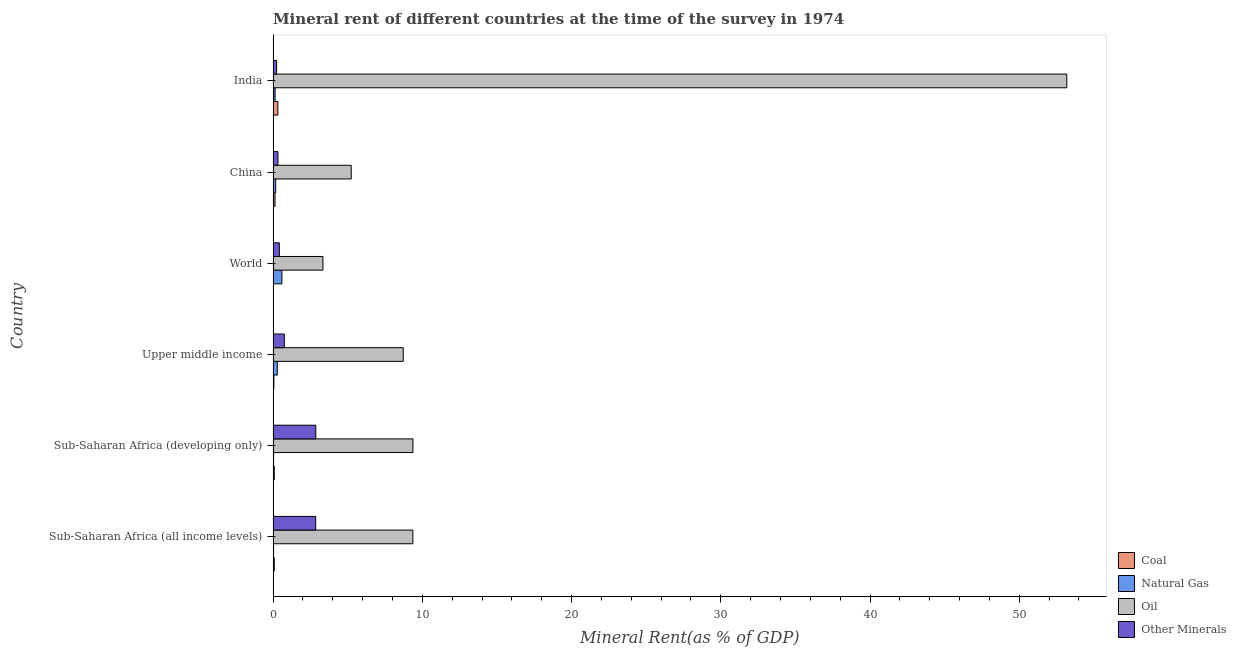Are the number of bars per tick equal to the number of legend labels?
Offer a very short reply. Yes. What is the label of the 4th group of bars from the top?
Provide a short and direct response. Upper middle income. What is the coal rent in Sub-Saharan Africa (developing only)?
Your response must be concise. 0.08. Across all countries, what is the maximum oil rent?
Ensure brevity in your answer.  53.18. Across all countries, what is the minimum  rent of other minerals?
Make the answer very short. 0.23. In which country was the  rent of other minerals minimum?
Offer a terse response. India. What is the total  rent of other minerals in the graph?
Your answer should be compact. 7.44. What is the difference between the coal rent in India and that in Sub-Saharan Africa (developing only)?
Provide a succinct answer. 0.24. What is the difference between the natural gas rent in Sub-Saharan Africa (developing only) and the  rent of other minerals in Upper middle income?
Provide a short and direct response. -0.72. What is the average  rent of other minerals per country?
Your answer should be very brief. 1.24. What is the difference between the coal rent and natural gas rent in Upper middle income?
Ensure brevity in your answer.  -0.23. What is the ratio of the oil rent in India to that in Sub-Saharan Africa (developing only)?
Ensure brevity in your answer.  5.68. What is the difference between the highest and the second highest coal rent?
Your response must be concise. 0.19. What is the difference between the highest and the lowest oil rent?
Your response must be concise. 49.85. Is the sum of the oil rent in China and Sub-Saharan Africa (all income levels) greater than the maximum  rent of other minerals across all countries?
Make the answer very short. Yes. Is it the case that in every country, the sum of the oil rent and natural gas rent is greater than the sum of  rent of other minerals and coal rent?
Your answer should be compact. Yes. What does the 2nd bar from the top in China represents?
Ensure brevity in your answer.  Oil. What does the 2nd bar from the bottom in Sub-Saharan Africa (developing only) represents?
Offer a terse response. Natural Gas. Is it the case that in every country, the sum of the coal rent and natural gas rent is greater than the oil rent?
Your answer should be compact. No. How many bars are there?
Ensure brevity in your answer.  24. Are all the bars in the graph horizontal?
Your response must be concise. Yes. What is the difference between two consecutive major ticks on the X-axis?
Make the answer very short. 10. Are the values on the major ticks of X-axis written in scientific E-notation?
Your answer should be very brief. No. Does the graph contain any zero values?
Offer a terse response. No. Does the graph contain grids?
Make the answer very short. No. How are the legend labels stacked?
Your response must be concise. Vertical. What is the title of the graph?
Give a very brief answer. Mineral rent of different countries at the time of the survey in 1974. Does "UNAIDS" appear as one of the legend labels in the graph?
Provide a short and direct response. No. What is the label or title of the X-axis?
Provide a short and direct response. Mineral Rent(as % of GDP). What is the label or title of the Y-axis?
Offer a terse response. Country. What is the Mineral Rent(as % of GDP) in Coal in Sub-Saharan Africa (all income levels)?
Ensure brevity in your answer.  0.08. What is the Mineral Rent(as % of GDP) of Natural Gas in Sub-Saharan Africa (all income levels)?
Give a very brief answer. 0.03. What is the Mineral Rent(as % of GDP) of Oil in Sub-Saharan Africa (all income levels)?
Offer a terse response. 9.37. What is the Mineral Rent(as % of GDP) of Other Minerals in Sub-Saharan Africa (all income levels)?
Provide a succinct answer. 2.85. What is the Mineral Rent(as % of GDP) in Coal in Sub-Saharan Africa (developing only)?
Provide a short and direct response. 0.08. What is the Mineral Rent(as % of GDP) in Natural Gas in Sub-Saharan Africa (developing only)?
Make the answer very short. 0.03. What is the Mineral Rent(as % of GDP) in Oil in Sub-Saharan Africa (developing only)?
Provide a short and direct response. 9.37. What is the Mineral Rent(as % of GDP) in Other Minerals in Sub-Saharan Africa (developing only)?
Your answer should be compact. 2.86. What is the Mineral Rent(as % of GDP) in Coal in Upper middle income?
Your answer should be very brief. 0.05. What is the Mineral Rent(as % of GDP) in Natural Gas in Upper middle income?
Provide a succinct answer. 0.28. What is the Mineral Rent(as % of GDP) in Oil in Upper middle income?
Your answer should be very brief. 8.72. What is the Mineral Rent(as % of GDP) of Other Minerals in Upper middle income?
Give a very brief answer. 0.75. What is the Mineral Rent(as % of GDP) of Coal in World?
Your answer should be compact. 0.01. What is the Mineral Rent(as % of GDP) in Natural Gas in World?
Your response must be concise. 0.59. What is the Mineral Rent(as % of GDP) of Oil in World?
Give a very brief answer. 3.34. What is the Mineral Rent(as % of GDP) of Other Minerals in World?
Make the answer very short. 0.42. What is the Mineral Rent(as % of GDP) of Coal in China?
Offer a very short reply. 0.13. What is the Mineral Rent(as % of GDP) of Natural Gas in China?
Your response must be concise. 0.17. What is the Mineral Rent(as % of GDP) of Oil in China?
Offer a terse response. 5.23. What is the Mineral Rent(as % of GDP) in Other Minerals in China?
Ensure brevity in your answer.  0.32. What is the Mineral Rent(as % of GDP) of Coal in India?
Provide a short and direct response. 0.32. What is the Mineral Rent(as % of GDP) in Natural Gas in India?
Your answer should be very brief. 0.13. What is the Mineral Rent(as % of GDP) in Oil in India?
Provide a succinct answer. 53.18. What is the Mineral Rent(as % of GDP) in Other Minerals in India?
Your response must be concise. 0.23. Across all countries, what is the maximum Mineral Rent(as % of GDP) of Coal?
Provide a succinct answer. 0.32. Across all countries, what is the maximum Mineral Rent(as % of GDP) in Natural Gas?
Your response must be concise. 0.59. Across all countries, what is the maximum Mineral Rent(as % of GDP) of Oil?
Your answer should be compact. 53.18. Across all countries, what is the maximum Mineral Rent(as % of GDP) of Other Minerals?
Offer a terse response. 2.86. Across all countries, what is the minimum Mineral Rent(as % of GDP) of Coal?
Ensure brevity in your answer.  0.01. Across all countries, what is the minimum Mineral Rent(as % of GDP) in Natural Gas?
Provide a succinct answer. 0.03. Across all countries, what is the minimum Mineral Rent(as % of GDP) in Oil?
Your answer should be compact. 3.34. Across all countries, what is the minimum Mineral Rent(as % of GDP) in Other Minerals?
Keep it short and to the point. 0.23. What is the total Mineral Rent(as % of GDP) of Coal in the graph?
Offer a terse response. 0.66. What is the total Mineral Rent(as % of GDP) of Natural Gas in the graph?
Make the answer very short. 1.23. What is the total Mineral Rent(as % of GDP) of Oil in the graph?
Your answer should be compact. 89.21. What is the total Mineral Rent(as % of GDP) in Other Minerals in the graph?
Your answer should be compact. 7.44. What is the difference between the Mineral Rent(as % of GDP) of Coal in Sub-Saharan Africa (all income levels) and that in Sub-Saharan Africa (developing only)?
Make the answer very short. -0. What is the difference between the Mineral Rent(as % of GDP) in Natural Gas in Sub-Saharan Africa (all income levels) and that in Sub-Saharan Africa (developing only)?
Provide a succinct answer. -0. What is the difference between the Mineral Rent(as % of GDP) of Oil in Sub-Saharan Africa (all income levels) and that in Sub-Saharan Africa (developing only)?
Your response must be concise. -0. What is the difference between the Mineral Rent(as % of GDP) in Other Minerals in Sub-Saharan Africa (all income levels) and that in Sub-Saharan Africa (developing only)?
Offer a terse response. -0. What is the difference between the Mineral Rent(as % of GDP) in Coal in Sub-Saharan Africa (all income levels) and that in Upper middle income?
Offer a terse response. 0.03. What is the difference between the Mineral Rent(as % of GDP) in Natural Gas in Sub-Saharan Africa (all income levels) and that in Upper middle income?
Make the answer very short. -0.25. What is the difference between the Mineral Rent(as % of GDP) of Oil in Sub-Saharan Africa (all income levels) and that in Upper middle income?
Keep it short and to the point. 0.64. What is the difference between the Mineral Rent(as % of GDP) in Other Minerals in Sub-Saharan Africa (all income levels) and that in Upper middle income?
Provide a succinct answer. 2.1. What is the difference between the Mineral Rent(as % of GDP) of Coal in Sub-Saharan Africa (all income levels) and that in World?
Offer a very short reply. 0.06. What is the difference between the Mineral Rent(as % of GDP) of Natural Gas in Sub-Saharan Africa (all income levels) and that in World?
Provide a short and direct response. -0.56. What is the difference between the Mineral Rent(as % of GDP) in Oil in Sub-Saharan Africa (all income levels) and that in World?
Offer a very short reply. 6.03. What is the difference between the Mineral Rent(as % of GDP) in Other Minerals in Sub-Saharan Africa (all income levels) and that in World?
Your response must be concise. 2.44. What is the difference between the Mineral Rent(as % of GDP) of Coal in Sub-Saharan Africa (all income levels) and that in China?
Your answer should be compact. -0.05. What is the difference between the Mineral Rent(as % of GDP) in Natural Gas in Sub-Saharan Africa (all income levels) and that in China?
Your response must be concise. -0.14. What is the difference between the Mineral Rent(as % of GDP) of Oil in Sub-Saharan Africa (all income levels) and that in China?
Provide a succinct answer. 4.13. What is the difference between the Mineral Rent(as % of GDP) in Other Minerals in Sub-Saharan Africa (all income levels) and that in China?
Offer a terse response. 2.53. What is the difference between the Mineral Rent(as % of GDP) of Coal in Sub-Saharan Africa (all income levels) and that in India?
Offer a very short reply. -0.24. What is the difference between the Mineral Rent(as % of GDP) in Natural Gas in Sub-Saharan Africa (all income levels) and that in India?
Ensure brevity in your answer.  -0.1. What is the difference between the Mineral Rent(as % of GDP) of Oil in Sub-Saharan Africa (all income levels) and that in India?
Offer a terse response. -43.82. What is the difference between the Mineral Rent(as % of GDP) in Other Minerals in Sub-Saharan Africa (all income levels) and that in India?
Your answer should be compact. 2.62. What is the difference between the Mineral Rent(as % of GDP) in Coal in Sub-Saharan Africa (developing only) and that in Upper middle income?
Your answer should be very brief. 0.03. What is the difference between the Mineral Rent(as % of GDP) of Natural Gas in Sub-Saharan Africa (developing only) and that in Upper middle income?
Make the answer very short. -0.25. What is the difference between the Mineral Rent(as % of GDP) in Oil in Sub-Saharan Africa (developing only) and that in Upper middle income?
Provide a succinct answer. 0.65. What is the difference between the Mineral Rent(as % of GDP) in Other Minerals in Sub-Saharan Africa (developing only) and that in Upper middle income?
Keep it short and to the point. 2.11. What is the difference between the Mineral Rent(as % of GDP) in Coal in Sub-Saharan Africa (developing only) and that in World?
Provide a succinct answer. 0.06. What is the difference between the Mineral Rent(as % of GDP) in Natural Gas in Sub-Saharan Africa (developing only) and that in World?
Offer a very short reply. -0.56. What is the difference between the Mineral Rent(as % of GDP) in Oil in Sub-Saharan Africa (developing only) and that in World?
Your answer should be very brief. 6.03. What is the difference between the Mineral Rent(as % of GDP) of Other Minerals in Sub-Saharan Africa (developing only) and that in World?
Make the answer very short. 2.44. What is the difference between the Mineral Rent(as % of GDP) in Coal in Sub-Saharan Africa (developing only) and that in China?
Provide a succinct answer. -0.05. What is the difference between the Mineral Rent(as % of GDP) in Natural Gas in Sub-Saharan Africa (developing only) and that in China?
Give a very brief answer. -0.14. What is the difference between the Mineral Rent(as % of GDP) of Oil in Sub-Saharan Africa (developing only) and that in China?
Your answer should be very brief. 4.14. What is the difference between the Mineral Rent(as % of GDP) of Other Minerals in Sub-Saharan Africa (developing only) and that in China?
Ensure brevity in your answer.  2.53. What is the difference between the Mineral Rent(as % of GDP) of Coal in Sub-Saharan Africa (developing only) and that in India?
Your answer should be very brief. -0.24. What is the difference between the Mineral Rent(as % of GDP) in Natural Gas in Sub-Saharan Africa (developing only) and that in India?
Ensure brevity in your answer.  -0.1. What is the difference between the Mineral Rent(as % of GDP) in Oil in Sub-Saharan Africa (developing only) and that in India?
Make the answer very short. -43.81. What is the difference between the Mineral Rent(as % of GDP) in Other Minerals in Sub-Saharan Africa (developing only) and that in India?
Provide a succinct answer. 2.62. What is the difference between the Mineral Rent(as % of GDP) in Coal in Upper middle income and that in World?
Keep it short and to the point. 0.04. What is the difference between the Mineral Rent(as % of GDP) of Natural Gas in Upper middle income and that in World?
Your answer should be compact. -0.31. What is the difference between the Mineral Rent(as % of GDP) of Oil in Upper middle income and that in World?
Give a very brief answer. 5.38. What is the difference between the Mineral Rent(as % of GDP) in Other Minerals in Upper middle income and that in World?
Your response must be concise. 0.33. What is the difference between the Mineral Rent(as % of GDP) in Coal in Upper middle income and that in China?
Offer a very short reply. -0.08. What is the difference between the Mineral Rent(as % of GDP) in Natural Gas in Upper middle income and that in China?
Offer a terse response. 0.11. What is the difference between the Mineral Rent(as % of GDP) of Oil in Upper middle income and that in China?
Offer a very short reply. 3.49. What is the difference between the Mineral Rent(as % of GDP) in Other Minerals in Upper middle income and that in China?
Ensure brevity in your answer.  0.43. What is the difference between the Mineral Rent(as % of GDP) in Coal in Upper middle income and that in India?
Provide a short and direct response. -0.27. What is the difference between the Mineral Rent(as % of GDP) of Natural Gas in Upper middle income and that in India?
Ensure brevity in your answer.  0.15. What is the difference between the Mineral Rent(as % of GDP) of Oil in Upper middle income and that in India?
Make the answer very short. -44.46. What is the difference between the Mineral Rent(as % of GDP) in Other Minerals in Upper middle income and that in India?
Provide a succinct answer. 0.52. What is the difference between the Mineral Rent(as % of GDP) in Coal in World and that in China?
Give a very brief answer. -0.12. What is the difference between the Mineral Rent(as % of GDP) of Natural Gas in World and that in China?
Keep it short and to the point. 0.42. What is the difference between the Mineral Rent(as % of GDP) in Oil in World and that in China?
Provide a short and direct response. -1.9. What is the difference between the Mineral Rent(as % of GDP) in Other Minerals in World and that in China?
Offer a very short reply. 0.09. What is the difference between the Mineral Rent(as % of GDP) of Coal in World and that in India?
Your answer should be compact. -0.31. What is the difference between the Mineral Rent(as % of GDP) in Natural Gas in World and that in India?
Give a very brief answer. 0.46. What is the difference between the Mineral Rent(as % of GDP) in Oil in World and that in India?
Give a very brief answer. -49.85. What is the difference between the Mineral Rent(as % of GDP) in Other Minerals in World and that in India?
Your answer should be very brief. 0.18. What is the difference between the Mineral Rent(as % of GDP) in Coal in China and that in India?
Ensure brevity in your answer.  -0.19. What is the difference between the Mineral Rent(as % of GDP) in Natural Gas in China and that in India?
Make the answer very short. 0.04. What is the difference between the Mineral Rent(as % of GDP) of Oil in China and that in India?
Ensure brevity in your answer.  -47.95. What is the difference between the Mineral Rent(as % of GDP) of Other Minerals in China and that in India?
Your answer should be compact. 0.09. What is the difference between the Mineral Rent(as % of GDP) of Coal in Sub-Saharan Africa (all income levels) and the Mineral Rent(as % of GDP) of Natural Gas in Sub-Saharan Africa (developing only)?
Keep it short and to the point. 0.05. What is the difference between the Mineral Rent(as % of GDP) of Coal in Sub-Saharan Africa (all income levels) and the Mineral Rent(as % of GDP) of Oil in Sub-Saharan Africa (developing only)?
Your answer should be very brief. -9.29. What is the difference between the Mineral Rent(as % of GDP) in Coal in Sub-Saharan Africa (all income levels) and the Mineral Rent(as % of GDP) in Other Minerals in Sub-Saharan Africa (developing only)?
Provide a short and direct response. -2.78. What is the difference between the Mineral Rent(as % of GDP) of Natural Gas in Sub-Saharan Africa (all income levels) and the Mineral Rent(as % of GDP) of Oil in Sub-Saharan Africa (developing only)?
Your answer should be very brief. -9.34. What is the difference between the Mineral Rent(as % of GDP) in Natural Gas in Sub-Saharan Africa (all income levels) and the Mineral Rent(as % of GDP) in Other Minerals in Sub-Saharan Africa (developing only)?
Make the answer very short. -2.83. What is the difference between the Mineral Rent(as % of GDP) of Oil in Sub-Saharan Africa (all income levels) and the Mineral Rent(as % of GDP) of Other Minerals in Sub-Saharan Africa (developing only)?
Provide a succinct answer. 6.51. What is the difference between the Mineral Rent(as % of GDP) in Coal in Sub-Saharan Africa (all income levels) and the Mineral Rent(as % of GDP) in Natural Gas in Upper middle income?
Provide a succinct answer. -0.2. What is the difference between the Mineral Rent(as % of GDP) of Coal in Sub-Saharan Africa (all income levels) and the Mineral Rent(as % of GDP) of Oil in Upper middle income?
Your answer should be compact. -8.64. What is the difference between the Mineral Rent(as % of GDP) of Coal in Sub-Saharan Africa (all income levels) and the Mineral Rent(as % of GDP) of Other Minerals in Upper middle income?
Provide a succinct answer. -0.67. What is the difference between the Mineral Rent(as % of GDP) in Natural Gas in Sub-Saharan Africa (all income levels) and the Mineral Rent(as % of GDP) in Oil in Upper middle income?
Your answer should be compact. -8.69. What is the difference between the Mineral Rent(as % of GDP) in Natural Gas in Sub-Saharan Africa (all income levels) and the Mineral Rent(as % of GDP) in Other Minerals in Upper middle income?
Keep it short and to the point. -0.72. What is the difference between the Mineral Rent(as % of GDP) of Oil in Sub-Saharan Africa (all income levels) and the Mineral Rent(as % of GDP) of Other Minerals in Upper middle income?
Provide a short and direct response. 8.61. What is the difference between the Mineral Rent(as % of GDP) of Coal in Sub-Saharan Africa (all income levels) and the Mineral Rent(as % of GDP) of Natural Gas in World?
Make the answer very short. -0.51. What is the difference between the Mineral Rent(as % of GDP) of Coal in Sub-Saharan Africa (all income levels) and the Mineral Rent(as % of GDP) of Oil in World?
Provide a short and direct response. -3.26. What is the difference between the Mineral Rent(as % of GDP) in Coal in Sub-Saharan Africa (all income levels) and the Mineral Rent(as % of GDP) in Other Minerals in World?
Keep it short and to the point. -0.34. What is the difference between the Mineral Rent(as % of GDP) in Natural Gas in Sub-Saharan Africa (all income levels) and the Mineral Rent(as % of GDP) in Oil in World?
Provide a succinct answer. -3.31. What is the difference between the Mineral Rent(as % of GDP) in Natural Gas in Sub-Saharan Africa (all income levels) and the Mineral Rent(as % of GDP) in Other Minerals in World?
Provide a succinct answer. -0.39. What is the difference between the Mineral Rent(as % of GDP) in Oil in Sub-Saharan Africa (all income levels) and the Mineral Rent(as % of GDP) in Other Minerals in World?
Provide a succinct answer. 8.95. What is the difference between the Mineral Rent(as % of GDP) in Coal in Sub-Saharan Africa (all income levels) and the Mineral Rent(as % of GDP) in Natural Gas in China?
Ensure brevity in your answer.  -0.1. What is the difference between the Mineral Rent(as % of GDP) in Coal in Sub-Saharan Africa (all income levels) and the Mineral Rent(as % of GDP) in Oil in China?
Give a very brief answer. -5.16. What is the difference between the Mineral Rent(as % of GDP) in Coal in Sub-Saharan Africa (all income levels) and the Mineral Rent(as % of GDP) in Other Minerals in China?
Provide a short and direct response. -0.25. What is the difference between the Mineral Rent(as % of GDP) of Natural Gas in Sub-Saharan Africa (all income levels) and the Mineral Rent(as % of GDP) of Oil in China?
Provide a succinct answer. -5.2. What is the difference between the Mineral Rent(as % of GDP) of Natural Gas in Sub-Saharan Africa (all income levels) and the Mineral Rent(as % of GDP) of Other Minerals in China?
Your answer should be compact. -0.29. What is the difference between the Mineral Rent(as % of GDP) in Oil in Sub-Saharan Africa (all income levels) and the Mineral Rent(as % of GDP) in Other Minerals in China?
Give a very brief answer. 9.04. What is the difference between the Mineral Rent(as % of GDP) in Coal in Sub-Saharan Africa (all income levels) and the Mineral Rent(as % of GDP) in Natural Gas in India?
Your answer should be compact. -0.06. What is the difference between the Mineral Rent(as % of GDP) in Coal in Sub-Saharan Africa (all income levels) and the Mineral Rent(as % of GDP) in Oil in India?
Provide a short and direct response. -53.11. What is the difference between the Mineral Rent(as % of GDP) of Coal in Sub-Saharan Africa (all income levels) and the Mineral Rent(as % of GDP) of Other Minerals in India?
Ensure brevity in your answer.  -0.16. What is the difference between the Mineral Rent(as % of GDP) in Natural Gas in Sub-Saharan Africa (all income levels) and the Mineral Rent(as % of GDP) in Oil in India?
Keep it short and to the point. -53.15. What is the difference between the Mineral Rent(as % of GDP) of Natural Gas in Sub-Saharan Africa (all income levels) and the Mineral Rent(as % of GDP) of Other Minerals in India?
Provide a short and direct response. -0.2. What is the difference between the Mineral Rent(as % of GDP) of Oil in Sub-Saharan Africa (all income levels) and the Mineral Rent(as % of GDP) of Other Minerals in India?
Provide a succinct answer. 9.13. What is the difference between the Mineral Rent(as % of GDP) in Coal in Sub-Saharan Africa (developing only) and the Mineral Rent(as % of GDP) in Natural Gas in Upper middle income?
Keep it short and to the point. -0.2. What is the difference between the Mineral Rent(as % of GDP) of Coal in Sub-Saharan Africa (developing only) and the Mineral Rent(as % of GDP) of Oil in Upper middle income?
Your response must be concise. -8.64. What is the difference between the Mineral Rent(as % of GDP) in Coal in Sub-Saharan Africa (developing only) and the Mineral Rent(as % of GDP) in Other Minerals in Upper middle income?
Keep it short and to the point. -0.67. What is the difference between the Mineral Rent(as % of GDP) of Natural Gas in Sub-Saharan Africa (developing only) and the Mineral Rent(as % of GDP) of Oil in Upper middle income?
Ensure brevity in your answer.  -8.69. What is the difference between the Mineral Rent(as % of GDP) of Natural Gas in Sub-Saharan Africa (developing only) and the Mineral Rent(as % of GDP) of Other Minerals in Upper middle income?
Provide a succinct answer. -0.72. What is the difference between the Mineral Rent(as % of GDP) in Oil in Sub-Saharan Africa (developing only) and the Mineral Rent(as % of GDP) in Other Minerals in Upper middle income?
Your answer should be very brief. 8.62. What is the difference between the Mineral Rent(as % of GDP) in Coal in Sub-Saharan Africa (developing only) and the Mineral Rent(as % of GDP) in Natural Gas in World?
Offer a very short reply. -0.51. What is the difference between the Mineral Rent(as % of GDP) of Coal in Sub-Saharan Africa (developing only) and the Mineral Rent(as % of GDP) of Oil in World?
Keep it short and to the point. -3.26. What is the difference between the Mineral Rent(as % of GDP) in Coal in Sub-Saharan Africa (developing only) and the Mineral Rent(as % of GDP) in Other Minerals in World?
Your answer should be compact. -0.34. What is the difference between the Mineral Rent(as % of GDP) in Natural Gas in Sub-Saharan Africa (developing only) and the Mineral Rent(as % of GDP) in Oil in World?
Keep it short and to the point. -3.31. What is the difference between the Mineral Rent(as % of GDP) in Natural Gas in Sub-Saharan Africa (developing only) and the Mineral Rent(as % of GDP) in Other Minerals in World?
Give a very brief answer. -0.39. What is the difference between the Mineral Rent(as % of GDP) of Oil in Sub-Saharan Africa (developing only) and the Mineral Rent(as % of GDP) of Other Minerals in World?
Keep it short and to the point. 8.95. What is the difference between the Mineral Rent(as % of GDP) in Coal in Sub-Saharan Africa (developing only) and the Mineral Rent(as % of GDP) in Natural Gas in China?
Your answer should be compact. -0.09. What is the difference between the Mineral Rent(as % of GDP) in Coal in Sub-Saharan Africa (developing only) and the Mineral Rent(as % of GDP) in Oil in China?
Offer a very short reply. -5.16. What is the difference between the Mineral Rent(as % of GDP) of Coal in Sub-Saharan Africa (developing only) and the Mineral Rent(as % of GDP) of Other Minerals in China?
Your response must be concise. -0.25. What is the difference between the Mineral Rent(as % of GDP) in Natural Gas in Sub-Saharan Africa (developing only) and the Mineral Rent(as % of GDP) in Oil in China?
Keep it short and to the point. -5.2. What is the difference between the Mineral Rent(as % of GDP) of Natural Gas in Sub-Saharan Africa (developing only) and the Mineral Rent(as % of GDP) of Other Minerals in China?
Make the answer very short. -0.29. What is the difference between the Mineral Rent(as % of GDP) of Oil in Sub-Saharan Africa (developing only) and the Mineral Rent(as % of GDP) of Other Minerals in China?
Your response must be concise. 9.05. What is the difference between the Mineral Rent(as % of GDP) of Coal in Sub-Saharan Africa (developing only) and the Mineral Rent(as % of GDP) of Natural Gas in India?
Your answer should be compact. -0.06. What is the difference between the Mineral Rent(as % of GDP) of Coal in Sub-Saharan Africa (developing only) and the Mineral Rent(as % of GDP) of Oil in India?
Ensure brevity in your answer.  -53.11. What is the difference between the Mineral Rent(as % of GDP) in Coal in Sub-Saharan Africa (developing only) and the Mineral Rent(as % of GDP) in Other Minerals in India?
Make the answer very short. -0.16. What is the difference between the Mineral Rent(as % of GDP) in Natural Gas in Sub-Saharan Africa (developing only) and the Mineral Rent(as % of GDP) in Oil in India?
Offer a very short reply. -53.15. What is the difference between the Mineral Rent(as % of GDP) of Natural Gas in Sub-Saharan Africa (developing only) and the Mineral Rent(as % of GDP) of Other Minerals in India?
Offer a very short reply. -0.2. What is the difference between the Mineral Rent(as % of GDP) of Oil in Sub-Saharan Africa (developing only) and the Mineral Rent(as % of GDP) of Other Minerals in India?
Provide a short and direct response. 9.14. What is the difference between the Mineral Rent(as % of GDP) in Coal in Upper middle income and the Mineral Rent(as % of GDP) in Natural Gas in World?
Keep it short and to the point. -0.54. What is the difference between the Mineral Rent(as % of GDP) in Coal in Upper middle income and the Mineral Rent(as % of GDP) in Oil in World?
Provide a short and direct response. -3.29. What is the difference between the Mineral Rent(as % of GDP) in Coal in Upper middle income and the Mineral Rent(as % of GDP) in Other Minerals in World?
Offer a very short reply. -0.37. What is the difference between the Mineral Rent(as % of GDP) in Natural Gas in Upper middle income and the Mineral Rent(as % of GDP) in Oil in World?
Keep it short and to the point. -3.06. What is the difference between the Mineral Rent(as % of GDP) of Natural Gas in Upper middle income and the Mineral Rent(as % of GDP) of Other Minerals in World?
Your answer should be compact. -0.14. What is the difference between the Mineral Rent(as % of GDP) of Oil in Upper middle income and the Mineral Rent(as % of GDP) of Other Minerals in World?
Your response must be concise. 8.3. What is the difference between the Mineral Rent(as % of GDP) in Coal in Upper middle income and the Mineral Rent(as % of GDP) in Natural Gas in China?
Your answer should be very brief. -0.12. What is the difference between the Mineral Rent(as % of GDP) of Coal in Upper middle income and the Mineral Rent(as % of GDP) of Oil in China?
Your response must be concise. -5.18. What is the difference between the Mineral Rent(as % of GDP) in Coal in Upper middle income and the Mineral Rent(as % of GDP) in Other Minerals in China?
Provide a short and direct response. -0.27. What is the difference between the Mineral Rent(as % of GDP) of Natural Gas in Upper middle income and the Mineral Rent(as % of GDP) of Oil in China?
Offer a very short reply. -4.95. What is the difference between the Mineral Rent(as % of GDP) in Natural Gas in Upper middle income and the Mineral Rent(as % of GDP) in Other Minerals in China?
Ensure brevity in your answer.  -0.04. What is the difference between the Mineral Rent(as % of GDP) in Oil in Upper middle income and the Mineral Rent(as % of GDP) in Other Minerals in China?
Give a very brief answer. 8.4. What is the difference between the Mineral Rent(as % of GDP) in Coal in Upper middle income and the Mineral Rent(as % of GDP) in Natural Gas in India?
Your answer should be compact. -0.08. What is the difference between the Mineral Rent(as % of GDP) in Coal in Upper middle income and the Mineral Rent(as % of GDP) in Oil in India?
Ensure brevity in your answer.  -53.13. What is the difference between the Mineral Rent(as % of GDP) of Coal in Upper middle income and the Mineral Rent(as % of GDP) of Other Minerals in India?
Provide a short and direct response. -0.18. What is the difference between the Mineral Rent(as % of GDP) in Natural Gas in Upper middle income and the Mineral Rent(as % of GDP) in Oil in India?
Provide a succinct answer. -52.9. What is the difference between the Mineral Rent(as % of GDP) of Natural Gas in Upper middle income and the Mineral Rent(as % of GDP) of Other Minerals in India?
Ensure brevity in your answer.  0.05. What is the difference between the Mineral Rent(as % of GDP) in Oil in Upper middle income and the Mineral Rent(as % of GDP) in Other Minerals in India?
Keep it short and to the point. 8.49. What is the difference between the Mineral Rent(as % of GDP) in Coal in World and the Mineral Rent(as % of GDP) in Natural Gas in China?
Offer a very short reply. -0.16. What is the difference between the Mineral Rent(as % of GDP) in Coal in World and the Mineral Rent(as % of GDP) in Oil in China?
Provide a succinct answer. -5.22. What is the difference between the Mineral Rent(as % of GDP) of Coal in World and the Mineral Rent(as % of GDP) of Other Minerals in China?
Your answer should be very brief. -0.31. What is the difference between the Mineral Rent(as % of GDP) of Natural Gas in World and the Mineral Rent(as % of GDP) of Oil in China?
Your response must be concise. -4.64. What is the difference between the Mineral Rent(as % of GDP) in Natural Gas in World and the Mineral Rent(as % of GDP) in Other Minerals in China?
Provide a short and direct response. 0.27. What is the difference between the Mineral Rent(as % of GDP) in Oil in World and the Mineral Rent(as % of GDP) in Other Minerals in China?
Your answer should be very brief. 3.01. What is the difference between the Mineral Rent(as % of GDP) in Coal in World and the Mineral Rent(as % of GDP) in Natural Gas in India?
Provide a succinct answer. -0.12. What is the difference between the Mineral Rent(as % of GDP) in Coal in World and the Mineral Rent(as % of GDP) in Oil in India?
Your answer should be compact. -53.17. What is the difference between the Mineral Rent(as % of GDP) in Coal in World and the Mineral Rent(as % of GDP) in Other Minerals in India?
Your response must be concise. -0.22. What is the difference between the Mineral Rent(as % of GDP) of Natural Gas in World and the Mineral Rent(as % of GDP) of Oil in India?
Offer a terse response. -52.59. What is the difference between the Mineral Rent(as % of GDP) of Natural Gas in World and the Mineral Rent(as % of GDP) of Other Minerals in India?
Give a very brief answer. 0.36. What is the difference between the Mineral Rent(as % of GDP) of Oil in World and the Mineral Rent(as % of GDP) of Other Minerals in India?
Your answer should be compact. 3.1. What is the difference between the Mineral Rent(as % of GDP) of Coal in China and the Mineral Rent(as % of GDP) of Natural Gas in India?
Give a very brief answer. -0. What is the difference between the Mineral Rent(as % of GDP) of Coal in China and the Mineral Rent(as % of GDP) of Oil in India?
Your answer should be very brief. -53.06. What is the difference between the Mineral Rent(as % of GDP) of Coal in China and the Mineral Rent(as % of GDP) of Other Minerals in India?
Ensure brevity in your answer.  -0.11. What is the difference between the Mineral Rent(as % of GDP) of Natural Gas in China and the Mineral Rent(as % of GDP) of Oil in India?
Provide a succinct answer. -53.01. What is the difference between the Mineral Rent(as % of GDP) in Natural Gas in China and the Mineral Rent(as % of GDP) in Other Minerals in India?
Ensure brevity in your answer.  -0.06. What is the difference between the Mineral Rent(as % of GDP) of Oil in China and the Mineral Rent(as % of GDP) of Other Minerals in India?
Make the answer very short. 5. What is the average Mineral Rent(as % of GDP) of Coal per country?
Ensure brevity in your answer.  0.11. What is the average Mineral Rent(as % of GDP) in Natural Gas per country?
Give a very brief answer. 0.21. What is the average Mineral Rent(as % of GDP) of Oil per country?
Provide a succinct answer. 14.87. What is the average Mineral Rent(as % of GDP) in Other Minerals per country?
Ensure brevity in your answer.  1.24. What is the difference between the Mineral Rent(as % of GDP) of Coal and Mineral Rent(as % of GDP) of Natural Gas in Sub-Saharan Africa (all income levels)?
Make the answer very short. 0.05. What is the difference between the Mineral Rent(as % of GDP) of Coal and Mineral Rent(as % of GDP) of Oil in Sub-Saharan Africa (all income levels)?
Provide a short and direct response. -9.29. What is the difference between the Mineral Rent(as % of GDP) of Coal and Mineral Rent(as % of GDP) of Other Minerals in Sub-Saharan Africa (all income levels)?
Provide a short and direct response. -2.78. What is the difference between the Mineral Rent(as % of GDP) in Natural Gas and Mineral Rent(as % of GDP) in Oil in Sub-Saharan Africa (all income levels)?
Your answer should be very brief. -9.33. What is the difference between the Mineral Rent(as % of GDP) of Natural Gas and Mineral Rent(as % of GDP) of Other Minerals in Sub-Saharan Africa (all income levels)?
Offer a very short reply. -2.82. What is the difference between the Mineral Rent(as % of GDP) in Oil and Mineral Rent(as % of GDP) in Other Minerals in Sub-Saharan Africa (all income levels)?
Provide a succinct answer. 6.51. What is the difference between the Mineral Rent(as % of GDP) in Coal and Mineral Rent(as % of GDP) in Natural Gas in Sub-Saharan Africa (developing only)?
Make the answer very short. 0.05. What is the difference between the Mineral Rent(as % of GDP) of Coal and Mineral Rent(as % of GDP) of Oil in Sub-Saharan Africa (developing only)?
Provide a short and direct response. -9.29. What is the difference between the Mineral Rent(as % of GDP) in Coal and Mineral Rent(as % of GDP) in Other Minerals in Sub-Saharan Africa (developing only)?
Provide a short and direct response. -2.78. What is the difference between the Mineral Rent(as % of GDP) of Natural Gas and Mineral Rent(as % of GDP) of Oil in Sub-Saharan Africa (developing only)?
Your answer should be compact. -9.34. What is the difference between the Mineral Rent(as % of GDP) of Natural Gas and Mineral Rent(as % of GDP) of Other Minerals in Sub-Saharan Africa (developing only)?
Keep it short and to the point. -2.83. What is the difference between the Mineral Rent(as % of GDP) of Oil and Mineral Rent(as % of GDP) of Other Minerals in Sub-Saharan Africa (developing only)?
Provide a succinct answer. 6.51. What is the difference between the Mineral Rent(as % of GDP) of Coal and Mineral Rent(as % of GDP) of Natural Gas in Upper middle income?
Your response must be concise. -0.23. What is the difference between the Mineral Rent(as % of GDP) of Coal and Mineral Rent(as % of GDP) of Oil in Upper middle income?
Ensure brevity in your answer.  -8.67. What is the difference between the Mineral Rent(as % of GDP) of Coal and Mineral Rent(as % of GDP) of Other Minerals in Upper middle income?
Your answer should be very brief. -0.7. What is the difference between the Mineral Rent(as % of GDP) of Natural Gas and Mineral Rent(as % of GDP) of Oil in Upper middle income?
Make the answer very short. -8.44. What is the difference between the Mineral Rent(as % of GDP) in Natural Gas and Mineral Rent(as % of GDP) in Other Minerals in Upper middle income?
Keep it short and to the point. -0.47. What is the difference between the Mineral Rent(as % of GDP) of Oil and Mineral Rent(as % of GDP) of Other Minerals in Upper middle income?
Your response must be concise. 7.97. What is the difference between the Mineral Rent(as % of GDP) in Coal and Mineral Rent(as % of GDP) in Natural Gas in World?
Your response must be concise. -0.58. What is the difference between the Mineral Rent(as % of GDP) of Coal and Mineral Rent(as % of GDP) of Oil in World?
Your answer should be very brief. -3.32. What is the difference between the Mineral Rent(as % of GDP) in Coal and Mineral Rent(as % of GDP) in Other Minerals in World?
Your response must be concise. -0.4. What is the difference between the Mineral Rent(as % of GDP) of Natural Gas and Mineral Rent(as % of GDP) of Oil in World?
Give a very brief answer. -2.75. What is the difference between the Mineral Rent(as % of GDP) in Natural Gas and Mineral Rent(as % of GDP) in Other Minerals in World?
Your answer should be compact. 0.17. What is the difference between the Mineral Rent(as % of GDP) of Oil and Mineral Rent(as % of GDP) of Other Minerals in World?
Your answer should be very brief. 2.92. What is the difference between the Mineral Rent(as % of GDP) in Coal and Mineral Rent(as % of GDP) in Natural Gas in China?
Your answer should be very brief. -0.04. What is the difference between the Mineral Rent(as % of GDP) of Coal and Mineral Rent(as % of GDP) of Oil in China?
Your answer should be very brief. -5.11. What is the difference between the Mineral Rent(as % of GDP) of Coal and Mineral Rent(as % of GDP) of Other Minerals in China?
Your response must be concise. -0.2. What is the difference between the Mineral Rent(as % of GDP) of Natural Gas and Mineral Rent(as % of GDP) of Oil in China?
Offer a terse response. -5.06. What is the difference between the Mineral Rent(as % of GDP) of Natural Gas and Mineral Rent(as % of GDP) of Other Minerals in China?
Your answer should be very brief. -0.15. What is the difference between the Mineral Rent(as % of GDP) of Oil and Mineral Rent(as % of GDP) of Other Minerals in China?
Your answer should be compact. 4.91. What is the difference between the Mineral Rent(as % of GDP) of Coal and Mineral Rent(as % of GDP) of Natural Gas in India?
Offer a very short reply. 0.19. What is the difference between the Mineral Rent(as % of GDP) in Coal and Mineral Rent(as % of GDP) in Oil in India?
Make the answer very short. -52.87. What is the difference between the Mineral Rent(as % of GDP) of Coal and Mineral Rent(as % of GDP) of Other Minerals in India?
Your answer should be very brief. 0.08. What is the difference between the Mineral Rent(as % of GDP) of Natural Gas and Mineral Rent(as % of GDP) of Oil in India?
Provide a short and direct response. -53.05. What is the difference between the Mineral Rent(as % of GDP) of Natural Gas and Mineral Rent(as % of GDP) of Other Minerals in India?
Provide a short and direct response. -0.1. What is the difference between the Mineral Rent(as % of GDP) in Oil and Mineral Rent(as % of GDP) in Other Minerals in India?
Your answer should be compact. 52.95. What is the ratio of the Mineral Rent(as % of GDP) of Coal in Sub-Saharan Africa (all income levels) to that in Upper middle income?
Your answer should be compact. 1.55. What is the ratio of the Mineral Rent(as % of GDP) in Natural Gas in Sub-Saharan Africa (all income levels) to that in Upper middle income?
Provide a short and direct response. 0.11. What is the ratio of the Mineral Rent(as % of GDP) of Oil in Sub-Saharan Africa (all income levels) to that in Upper middle income?
Offer a terse response. 1.07. What is the ratio of the Mineral Rent(as % of GDP) in Other Minerals in Sub-Saharan Africa (all income levels) to that in Upper middle income?
Ensure brevity in your answer.  3.8. What is the ratio of the Mineral Rent(as % of GDP) in Coal in Sub-Saharan Africa (all income levels) to that in World?
Provide a short and direct response. 6.25. What is the ratio of the Mineral Rent(as % of GDP) of Natural Gas in Sub-Saharan Africa (all income levels) to that in World?
Make the answer very short. 0.05. What is the ratio of the Mineral Rent(as % of GDP) in Oil in Sub-Saharan Africa (all income levels) to that in World?
Provide a short and direct response. 2.81. What is the ratio of the Mineral Rent(as % of GDP) of Other Minerals in Sub-Saharan Africa (all income levels) to that in World?
Give a very brief answer. 6.84. What is the ratio of the Mineral Rent(as % of GDP) of Coal in Sub-Saharan Africa (all income levels) to that in China?
Your answer should be very brief. 0.59. What is the ratio of the Mineral Rent(as % of GDP) in Natural Gas in Sub-Saharan Africa (all income levels) to that in China?
Your answer should be very brief. 0.18. What is the ratio of the Mineral Rent(as % of GDP) of Oil in Sub-Saharan Africa (all income levels) to that in China?
Ensure brevity in your answer.  1.79. What is the ratio of the Mineral Rent(as % of GDP) in Other Minerals in Sub-Saharan Africa (all income levels) to that in China?
Offer a terse response. 8.81. What is the ratio of the Mineral Rent(as % of GDP) in Coal in Sub-Saharan Africa (all income levels) to that in India?
Provide a short and direct response. 0.24. What is the ratio of the Mineral Rent(as % of GDP) of Natural Gas in Sub-Saharan Africa (all income levels) to that in India?
Offer a terse response. 0.23. What is the ratio of the Mineral Rent(as % of GDP) of Oil in Sub-Saharan Africa (all income levels) to that in India?
Your response must be concise. 0.18. What is the ratio of the Mineral Rent(as % of GDP) of Other Minerals in Sub-Saharan Africa (all income levels) to that in India?
Your response must be concise. 12.21. What is the ratio of the Mineral Rent(as % of GDP) of Coal in Sub-Saharan Africa (developing only) to that in Upper middle income?
Offer a very short reply. 1.55. What is the ratio of the Mineral Rent(as % of GDP) in Natural Gas in Sub-Saharan Africa (developing only) to that in Upper middle income?
Provide a short and direct response. 0.11. What is the ratio of the Mineral Rent(as % of GDP) in Oil in Sub-Saharan Africa (developing only) to that in Upper middle income?
Provide a short and direct response. 1.07. What is the ratio of the Mineral Rent(as % of GDP) of Other Minerals in Sub-Saharan Africa (developing only) to that in Upper middle income?
Your answer should be compact. 3.81. What is the ratio of the Mineral Rent(as % of GDP) of Coal in Sub-Saharan Africa (developing only) to that in World?
Offer a very short reply. 6.25. What is the ratio of the Mineral Rent(as % of GDP) in Natural Gas in Sub-Saharan Africa (developing only) to that in World?
Your answer should be very brief. 0.05. What is the ratio of the Mineral Rent(as % of GDP) in Oil in Sub-Saharan Africa (developing only) to that in World?
Offer a terse response. 2.81. What is the ratio of the Mineral Rent(as % of GDP) in Other Minerals in Sub-Saharan Africa (developing only) to that in World?
Offer a terse response. 6.85. What is the ratio of the Mineral Rent(as % of GDP) of Coal in Sub-Saharan Africa (developing only) to that in China?
Your answer should be compact. 0.6. What is the ratio of the Mineral Rent(as % of GDP) of Natural Gas in Sub-Saharan Africa (developing only) to that in China?
Your answer should be very brief. 0.18. What is the ratio of the Mineral Rent(as % of GDP) in Oil in Sub-Saharan Africa (developing only) to that in China?
Provide a succinct answer. 1.79. What is the ratio of the Mineral Rent(as % of GDP) of Other Minerals in Sub-Saharan Africa (developing only) to that in China?
Provide a short and direct response. 8.83. What is the ratio of the Mineral Rent(as % of GDP) of Coal in Sub-Saharan Africa (developing only) to that in India?
Offer a terse response. 0.24. What is the ratio of the Mineral Rent(as % of GDP) of Natural Gas in Sub-Saharan Africa (developing only) to that in India?
Keep it short and to the point. 0.23. What is the ratio of the Mineral Rent(as % of GDP) in Oil in Sub-Saharan Africa (developing only) to that in India?
Make the answer very short. 0.18. What is the ratio of the Mineral Rent(as % of GDP) in Other Minerals in Sub-Saharan Africa (developing only) to that in India?
Ensure brevity in your answer.  12.22. What is the ratio of the Mineral Rent(as % of GDP) of Coal in Upper middle income to that in World?
Your answer should be compact. 4.04. What is the ratio of the Mineral Rent(as % of GDP) of Natural Gas in Upper middle income to that in World?
Your answer should be very brief. 0.48. What is the ratio of the Mineral Rent(as % of GDP) of Oil in Upper middle income to that in World?
Provide a succinct answer. 2.61. What is the ratio of the Mineral Rent(as % of GDP) of Other Minerals in Upper middle income to that in World?
Keep it short and to the point. 1.8. What is the ratio of the Mineral Rent(as % of GDP) in Coal in Upper middle income to that in China?
Your response must be concise. 0.38. What is the ratio of the Mineral Rent(as % of GDP) of Natural Gas in Upper middle income to that in China?
Provide a succinct answer. 1.64. What is the ratio of the Mineral Rent(as % of GDP) in Oil in Upper middle income to that in China?
Ensure brevity in your answer.  1.67. What is the ratio of the Mineral Rent(as % of GDP) of Other Minerals in Upper middle income to that in China?
Provide a succinct answer. 2.32. What is the ratio of the Mineral Rent(as % of GDP) of Coal in Upper middle income to that in India?
Provide a succinct answer. 0.16. What is the ratio of the Mineral Rent(as % of GDP) of Natural Gas in Upper middle income to that in India?
Your answer should be very brief. 2.13. What is the ratio of the Mineral Rent(as % of GDP) of Oil in Upper middle income to that in India?
Give a very brief answer. 0.16. What is the ratio of the Mineral Rent(as % of GDP) of Other Minerals in Upper middle income to that in India?
Provide a short and direct response. 3.21. What is the ratio of the Mineral Rent(as % of GDP) in Coal in World to that in China?
Offer a terse response. 0.1. What is the ratio of the Mineral Rent(as % of GDP) in Natural Gas in World to that in China?
Provide a succinct answer. 3.44. What is the ratio of the Mineral Rent(as % of GDP) in Oil in World to that in China?
Make the answer very short. 0.64. What is the ratio of the Mineral Rent(as % of GDP) in Other Minerals in World to that in China?
Keep it short and to the point. 1.29. What is the ratio of the Mineral Rent(as % of GDP) of Coal in World to that in India?
Provide a short and direct response. 0.04. What is the ratio of the Mineral Rent(as % of GDP) in Natural Gas in World to that in India?
Provide a short and direct response. 4.46. What is the ratio of the Mineral Rent(as % of GDP) in Oil in World to that in India?
Keep it short and to the point. 0.06. What is the ratio of the Mineral Rent(as % of GDP) in Other Minerals in World to that in India?
Provide a succinct answer. 1.78. What is the ratio of the Mineral Rent(as % of GDP) in Coal in China to that in India?
Ensure brevity in your answer.  0.4. What is the ratio of the Mineral Rent(as % of GDP) of Natural Gas in China to that in India?
Provide a short and direct response. 1.3. What is the ratio of the Mineral Rent(as % of GDP) of Oil in China to that in India?
Offer a terse response. 0.1. What is the ratio of the Mineral Rent(as % of GDP) of Other Minerals in China to that in India?
Offer a terse response. 1.38. What is the difference between the highest and the second highest Mineral Rent(as % of GDP) in Coal?
Offer a very short reply. 0.19. What is the difference between the highest and the second highest Mineral Rent(as % of GDP) in Natural Gas?
Keep it short and to the point. 0.31. What is the difference between the highest and the second highest Mineral Rent(as % of GDP) of Oil?
Offer a terse response. 43.81. What is the difference between the highest and the second highest Mineral Rent(as % of GDP) of Other Minerals?
Your answer should be compact. 0. What is the difference between the highest and the lowest Mineral Rent(as % of GDP) in Coal?
Provide a short and direct response. 0.31. What is the difference between the highest and the lowest Mineral Rent(as % of GDP) of Natural Gas?
Your response must be concise. 0.56. What is the difference between the highest and the lowest Mineral Rent(as % of GDP) of Oil?
Offer a terse response. 49.85. What is the difference between the highest and the lowest Mineral Rent(as % of GDP) in Other Minerals?
Your response must be concise. 2.62. 